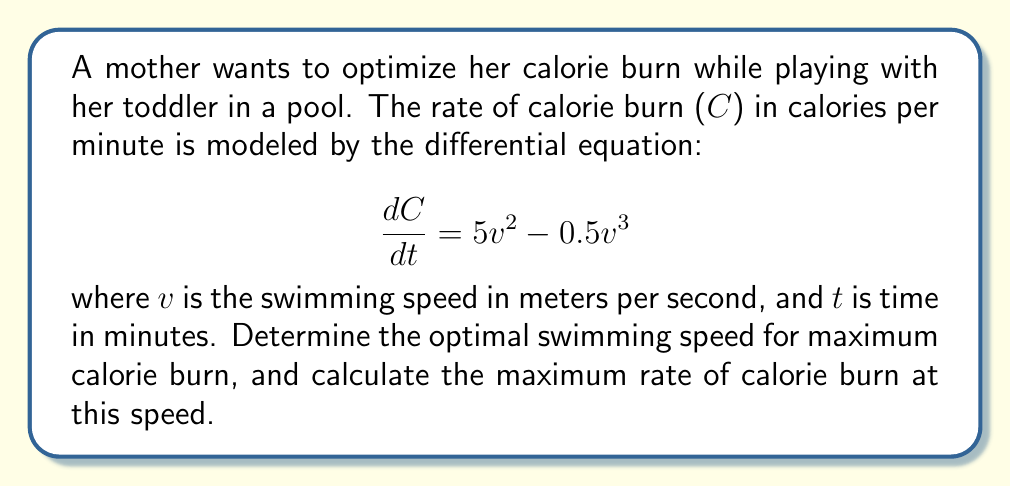Solve this math problem. To find the optimal swimming speed for maximum calorie burn, we need to find the maximum value of $\frac{dC}{dt}$.

1. Let's define a function $f(v) = 5v^2 - 0.5v^3$, which represents $\frac{dC}{dt}$.

2. To find the maximum value of $f(v)$, we need to find where its derivative equals zero:

   $$\frac{df}{dv} = 10v - 1.5v^2$$

3. Set this equal to zero and solve for v:

   $$10v - 1.5v^2 = 0$$
   $$v(10 - 1.5v) = 0$$

   This gives us two solutions: $v = 0$ or $v = \frac{20}{3}$

4. The second derivative test confirms that $v = \frac{20}{3}$ is a maximum:

   $$\frac{d^2f}{dv^2} = 10 - 3v$$
   
   At $v = \frac{20}{3}$, $\frac{d^2f}{dv^2} < 0$, confirming it's a maximum.

5. To find the maximum rate of calorie burn, substitute $v = \frac{20}{3}$ into the original equation:

   $$\frac{dC}{dt} = 5(\frac{20}{3})^2 - 0.5(\frac{20}{3})^3$$
   $$= 5 \cdot \frac{400}{9} - 0.5 \cdot \frac{8000}{27}$$
   $$= \frac{2000}{9} - \frac{4000}{27}$$
   $$= \frac{6000}{27} - \frac{4000}{27}$$
   $$= \frac{2000}{27}$$
   $$\approx 74.07$$

Therefore, the optimal swimming speed is $\frac{20}{3}$ m/s, and the maximum rate of calorie burn at this speed is $\frac{2000}{27}$ calories per minute.
Answer: Optimal swimming speed: $\frac{20}{3}$ m/s ≈ 6.67 m/s
Maximum rate of calorie burn: $\frac{2000}{27}$ calories/minute ≈ 74.07 calories/minute 